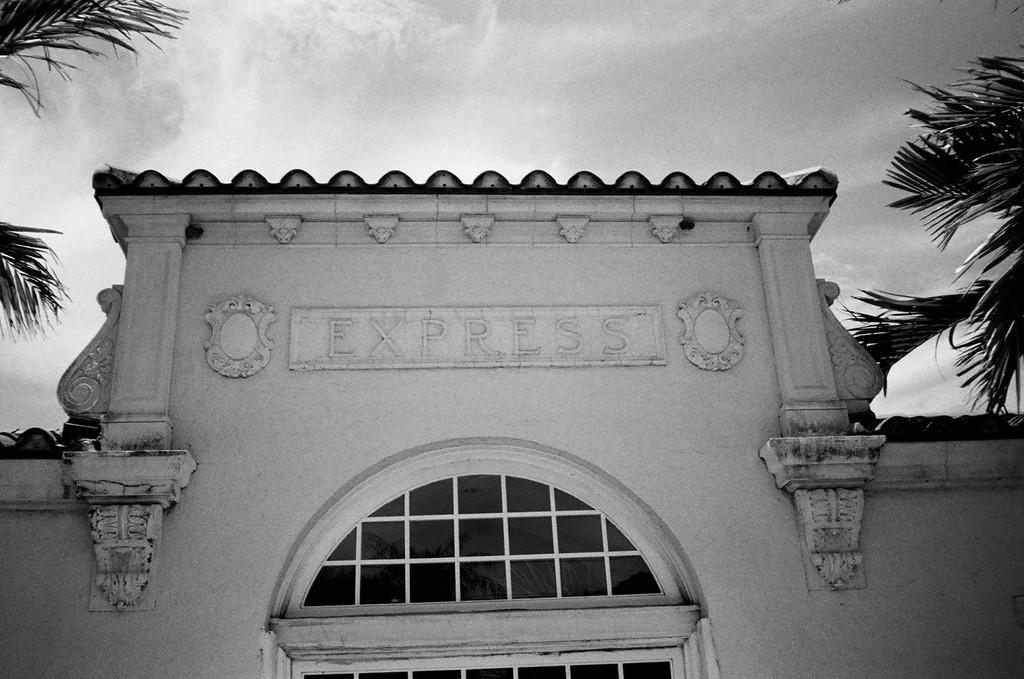Could you give a brief overview of what you see in this image? This is a black and white image. In this image we can see there is a building. On the right and left side of the image there is a coconut tree. In the background there is a sky. 